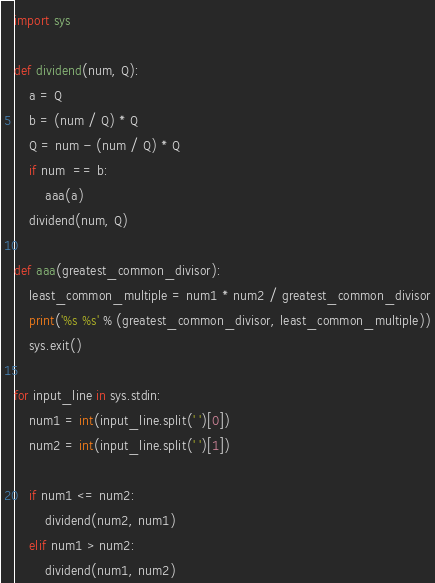Convert code to text. <code><loc_0><loc_0><loc_500><loc_500><_Python_>import sys

def dividend(num, Q):
    a = Q
    b = (num / Q) * Q
    Q = num - (num / Q) * Q
    if num  == b:
        aaa(a)
    dividend(num, Q)
    
def aaa(greatest_common_divisor):
    least_common_multiple = num1 * num2 / greatest_common_divisor
    print('%s %s' % (greatest_common_divisor, least_common_multiple))
    sys.exit()

for input_line in sys.stdin:
    num1 = int(input_line.split(' ')[0])
    num2 = int(input_line.split(' ')[1])
    
    if num1 <= num2:
        dividend(num2, num1)
    elif num1 > num2:
        dividend(num1, num2)</code> 